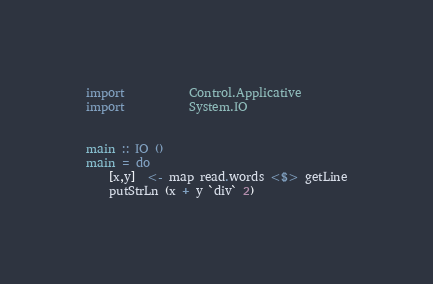Convert code to text. <code><loc_0><loc_0><loc_500><loc_500><_Haskell_>import           Control.Applicative
import           System.IO


main :: IO ()
main = do
    [x,y]  <- map read.words <$> getLine
    putStrLn (x + y `div` 2)
</code> 